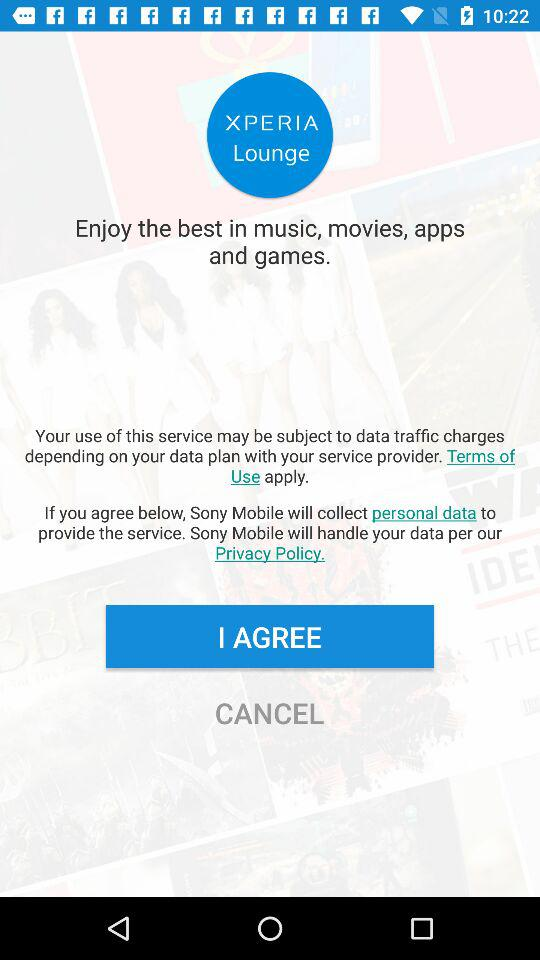What is the application name? The application name is "XPERIA Lounge". 